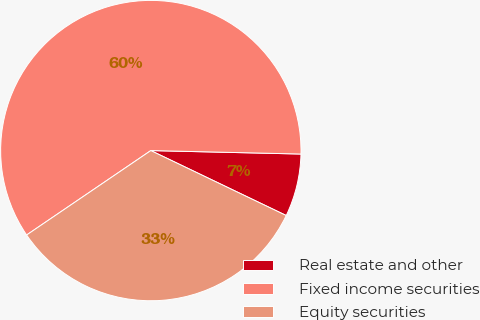Convert chart to OTSL. <chart><loc_0><loc_0><loc_500><loc_500><pie_chart><fcel>Real estate and other<fcel>Fixed income securities<fcel>Equity securities<nl><fcel>6.75%<fcel>59.87%<fcel>33.38%<nl></chart> 